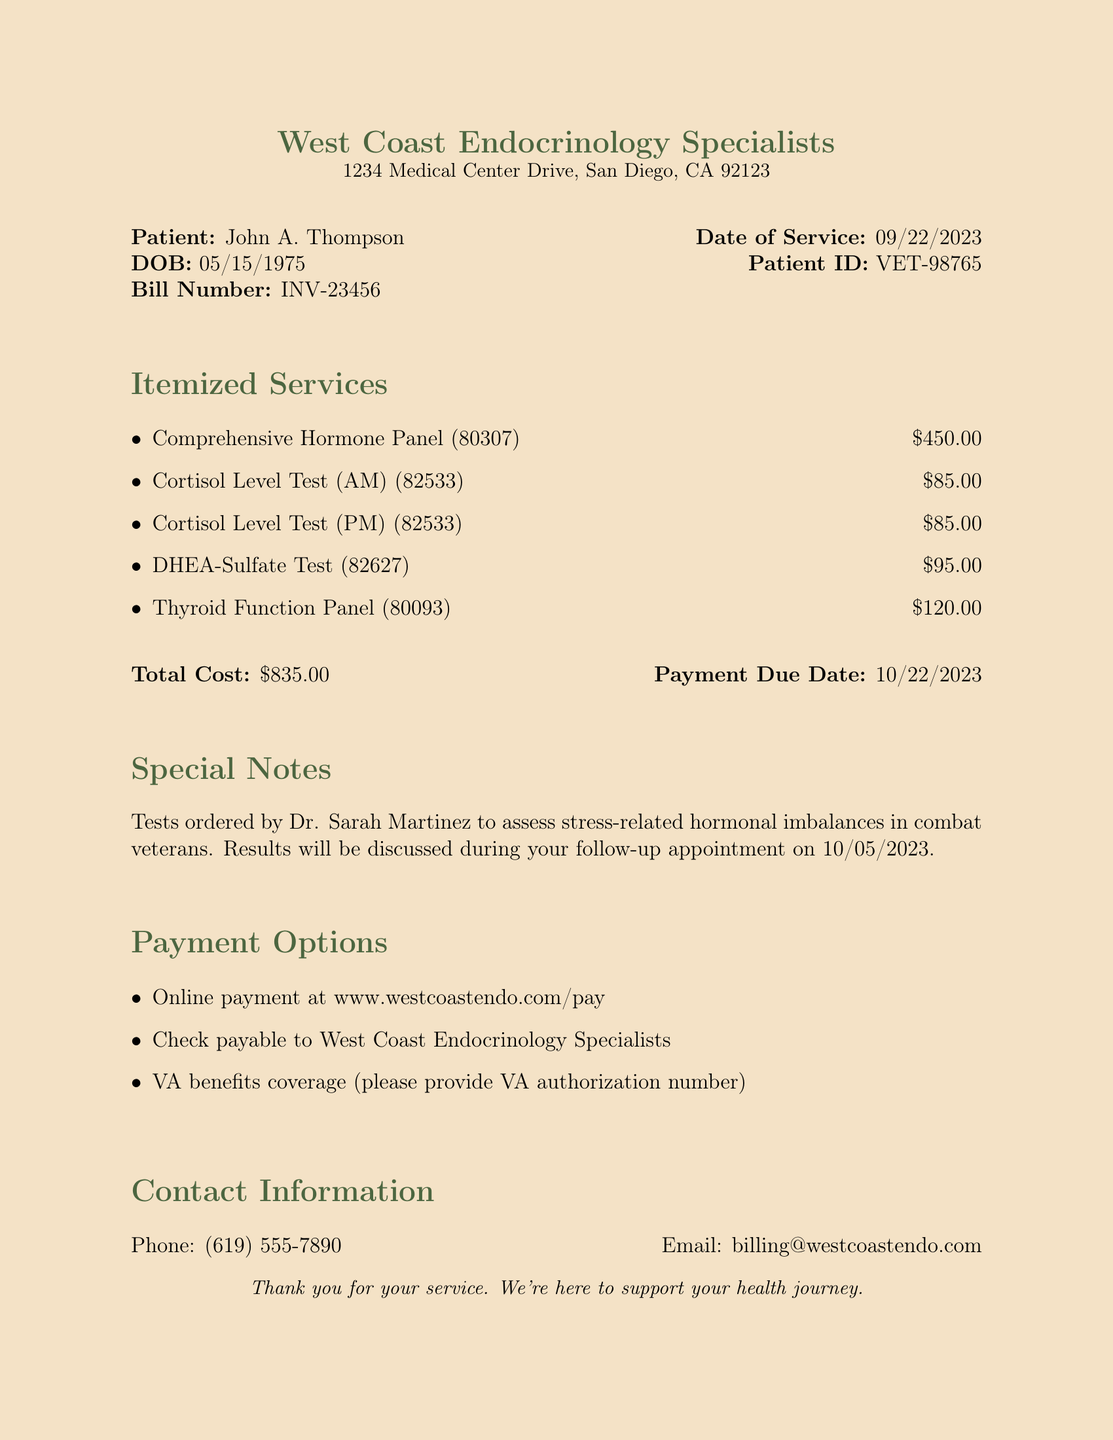What is the name of the clinic? The clinic's name is stated in the document, which is West Coast Endocrinology Specialists.
Answer: West Coast Endocrinology Specialists What is the patient's date of birth? The patient's date of birth is listed in the patient information section of the document as 05/15/1975.
Answer: 05/15/1975 What is the total cost of the services? The document specifies the total cost at the bottom, which is $835.00.
Answer: $835.00 Who ordered the tests? The document mentions that the tests were ordered by Dr. Sarah Martinez.
Answer: Dr. Sarah Martinez What is the payment due date? The payment due date is provided in the bill details, which is 10/22/2023.
Answer: 10/22/2023 How many cortisol level tests were performed? The itemized services list two cortisol level tests: AM and PM, totaling two tests.
Answer: 2 What is the CPT code for the DHEA-Sulfate Test? The CPT code for the DHEA-Sulfate Test is indicated in the document as 82627.
Answer: 82627 What is one option for payment? The document lists several payment options; one is online payment at the specified website.
Answer: Online payment at www.westcoastendo.com/pay When is the follow-up appointment scheduled? The follow-up appointment is mentioned to be on 10/05/2023 in the special notes section.
Answer: 10/05/2023 